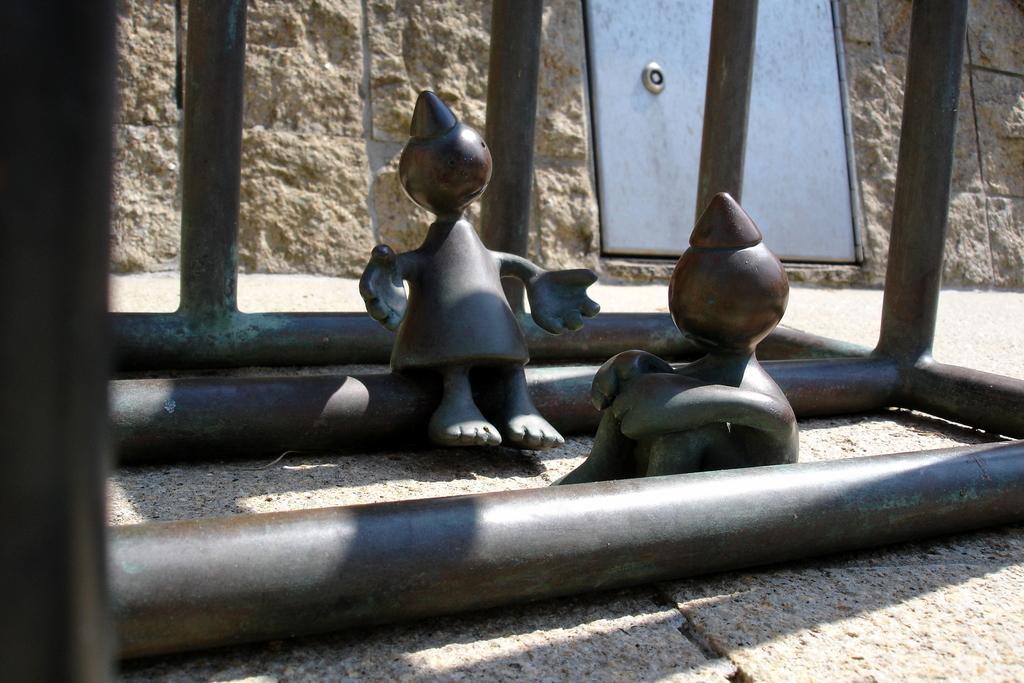Please provide a concise description of this image. In the center of the image we can see two toy type objects, which are in brown color. And we can see the roads around them. In the background there is a wall, door and a few other objects. 